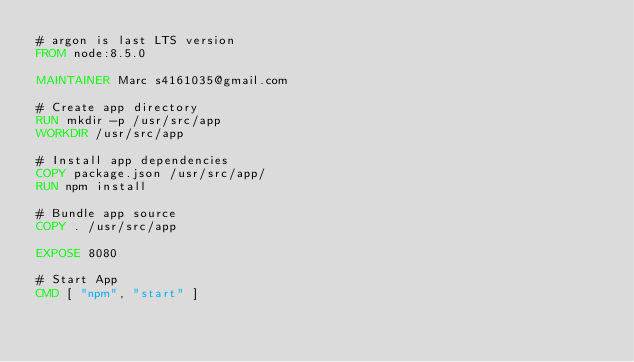<code> <loc_0><loc_0><loc_500><loc_500><_Dockerfile_># argon is last LTS version
FROM node:8.5.0

MAINTAINER Marc s4161035@gmail.com

# Create app directory
RUN mkdir -p /usr/src/app
WORKDIR /usr/src/app

# Install app dependencies
COPY package.json /usr/src/app/
RUN npm install

# Bundle app source
COPY . /usr/src/app

EXPOSE 8080

# Start App
CMD [ "npm", "start" ]</code> 